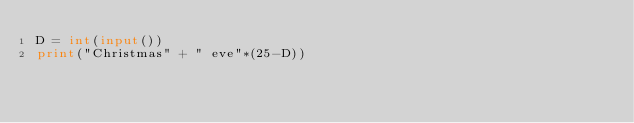Convert code to text. <code><loc_0><loc_0><loc_500><loc_500><_Python_>D = int(input())
print("Christmas" + " eve"*(25-D))</code> 